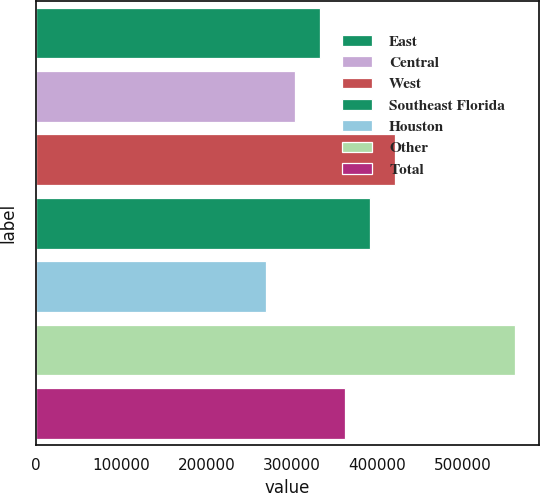Convert chart. <chart><loc_0><loc_0><loc_500><loc_500><bar_chart><fcel>East<fcel>Central<fcel>West<fcel>Southeast Florida<fcel>Houston<fcel>Other<fcel>Total<nl><fcel>333100<fcel>304000<fcel>420400<fcel>391300<fcel>270000<fcel>561000<fcel>362200<nl></chart> 